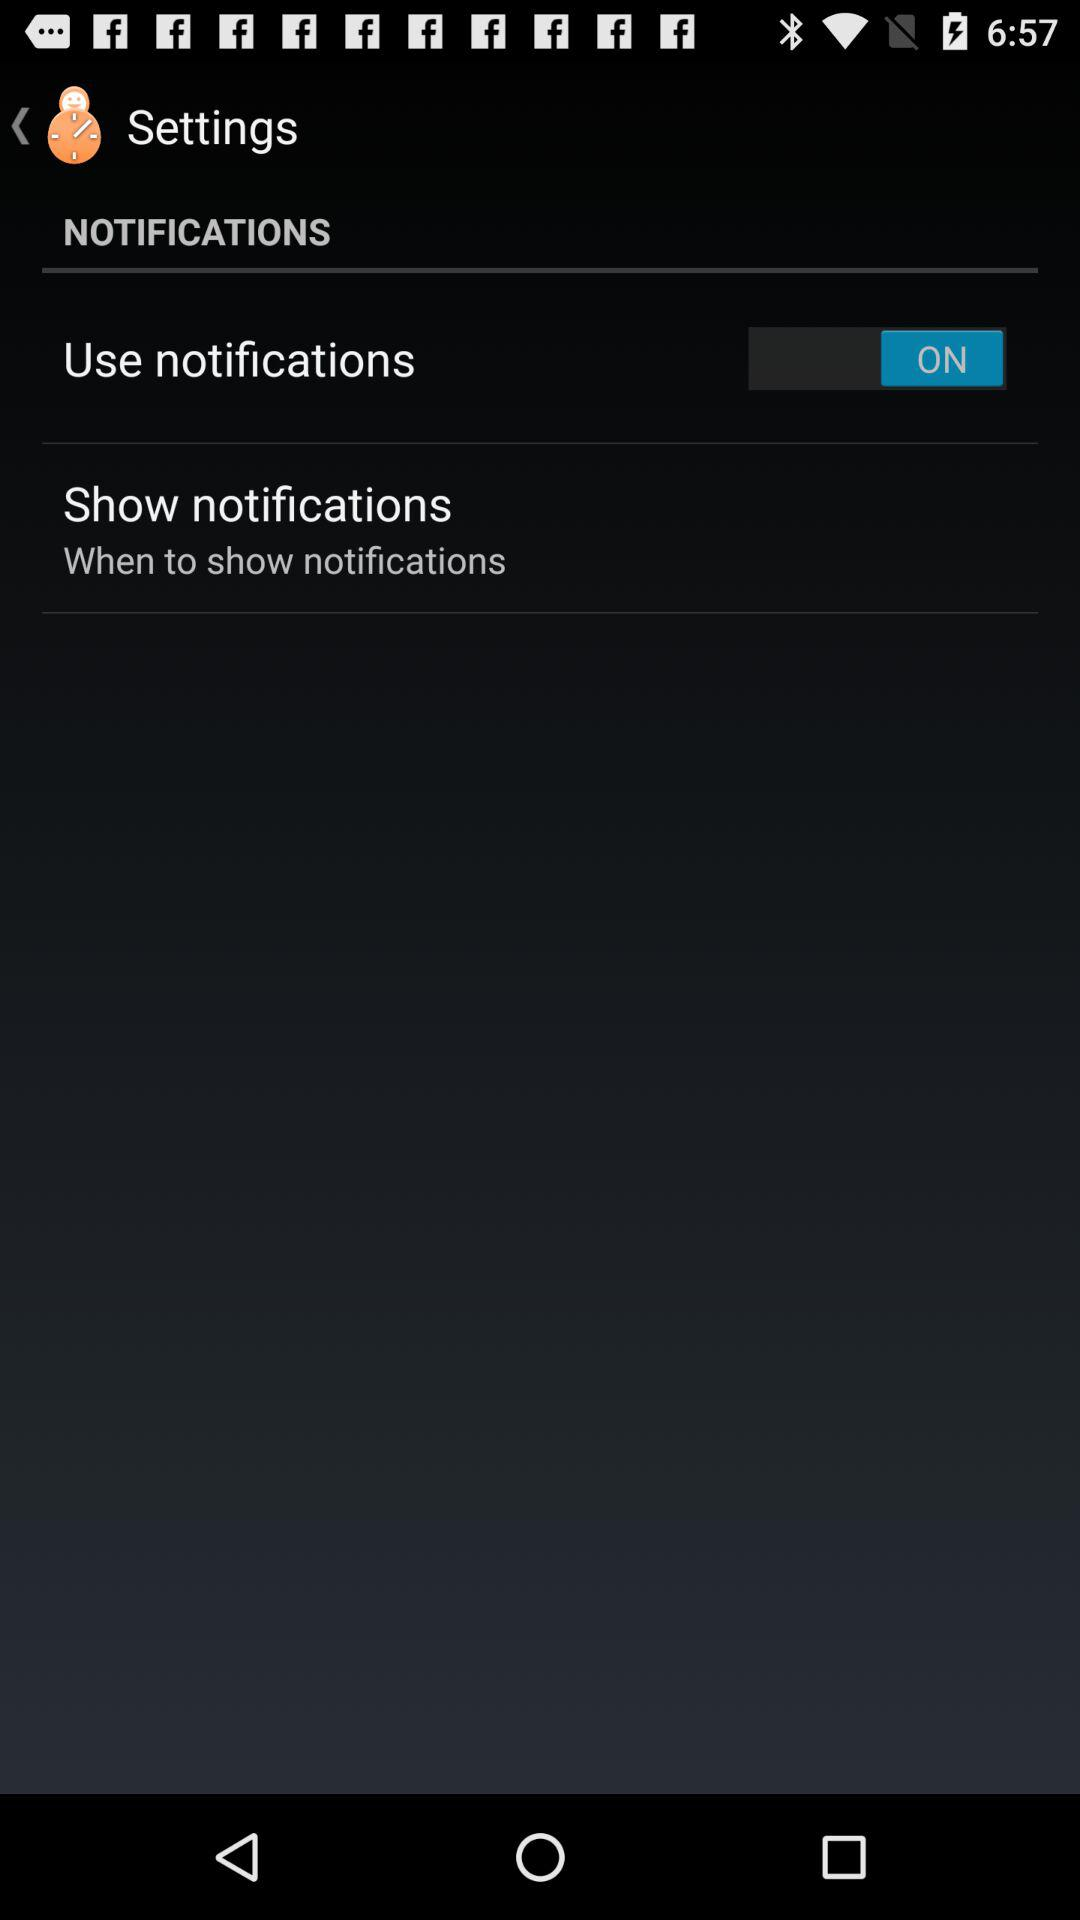What is the status of "Use notifications"? The status is "on". 